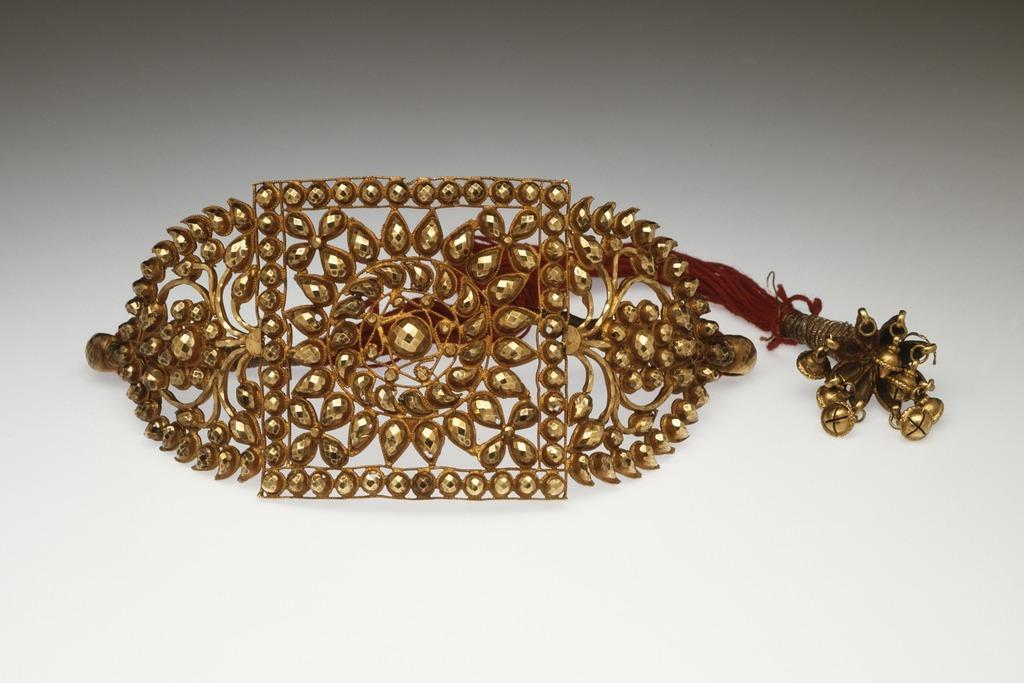What is the main subject of the picture? The main subject of the picture is an ornament. Where is the ornament located in the image? The ornament is placed on a white surface. What color is the coating on the ornament? The ornament has a yellow coating. What type of van can be seen in the background of the image? There is no van present in the image; it only features an ornament on a white surface. What song is playing in the background of the image? There is no audio or music present in the image, so it cannot be determined if a song is playing. 